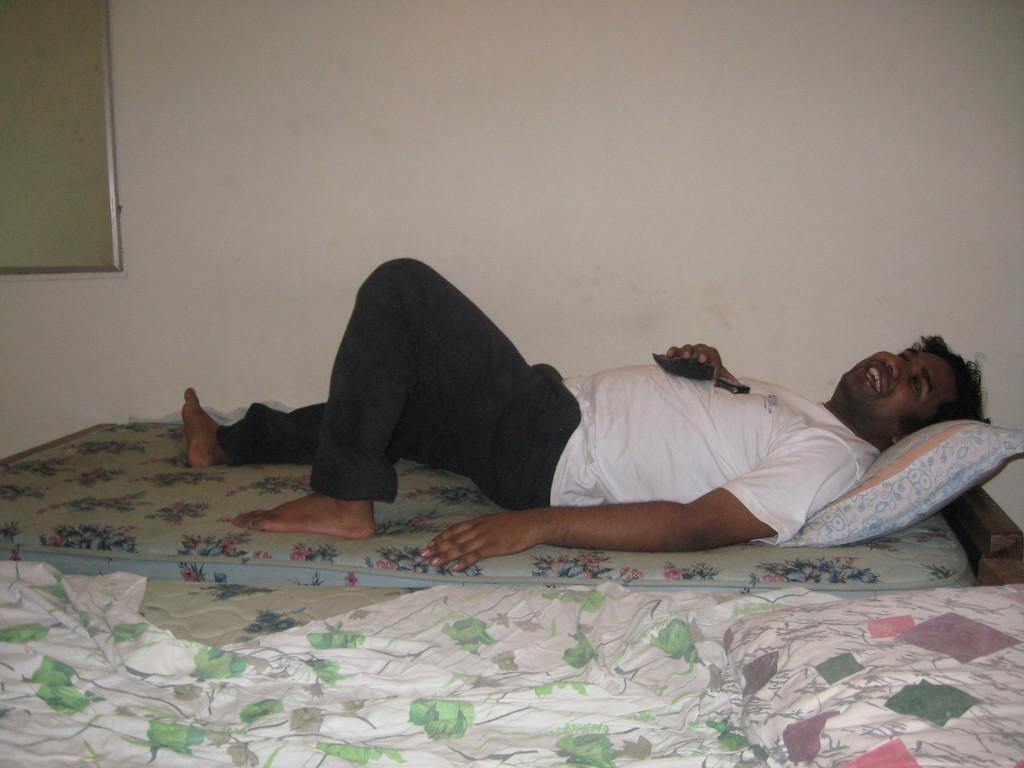How would you summarize this image in a sentence or two? This image is clicked inside the room. There are 2 cots and bed sheet on the cot which is in the bottom. There are 2 pillows. A man is lying on the bed which is in the middle of the image. The man is wearing white shirt and black pant , he is also smiling. 